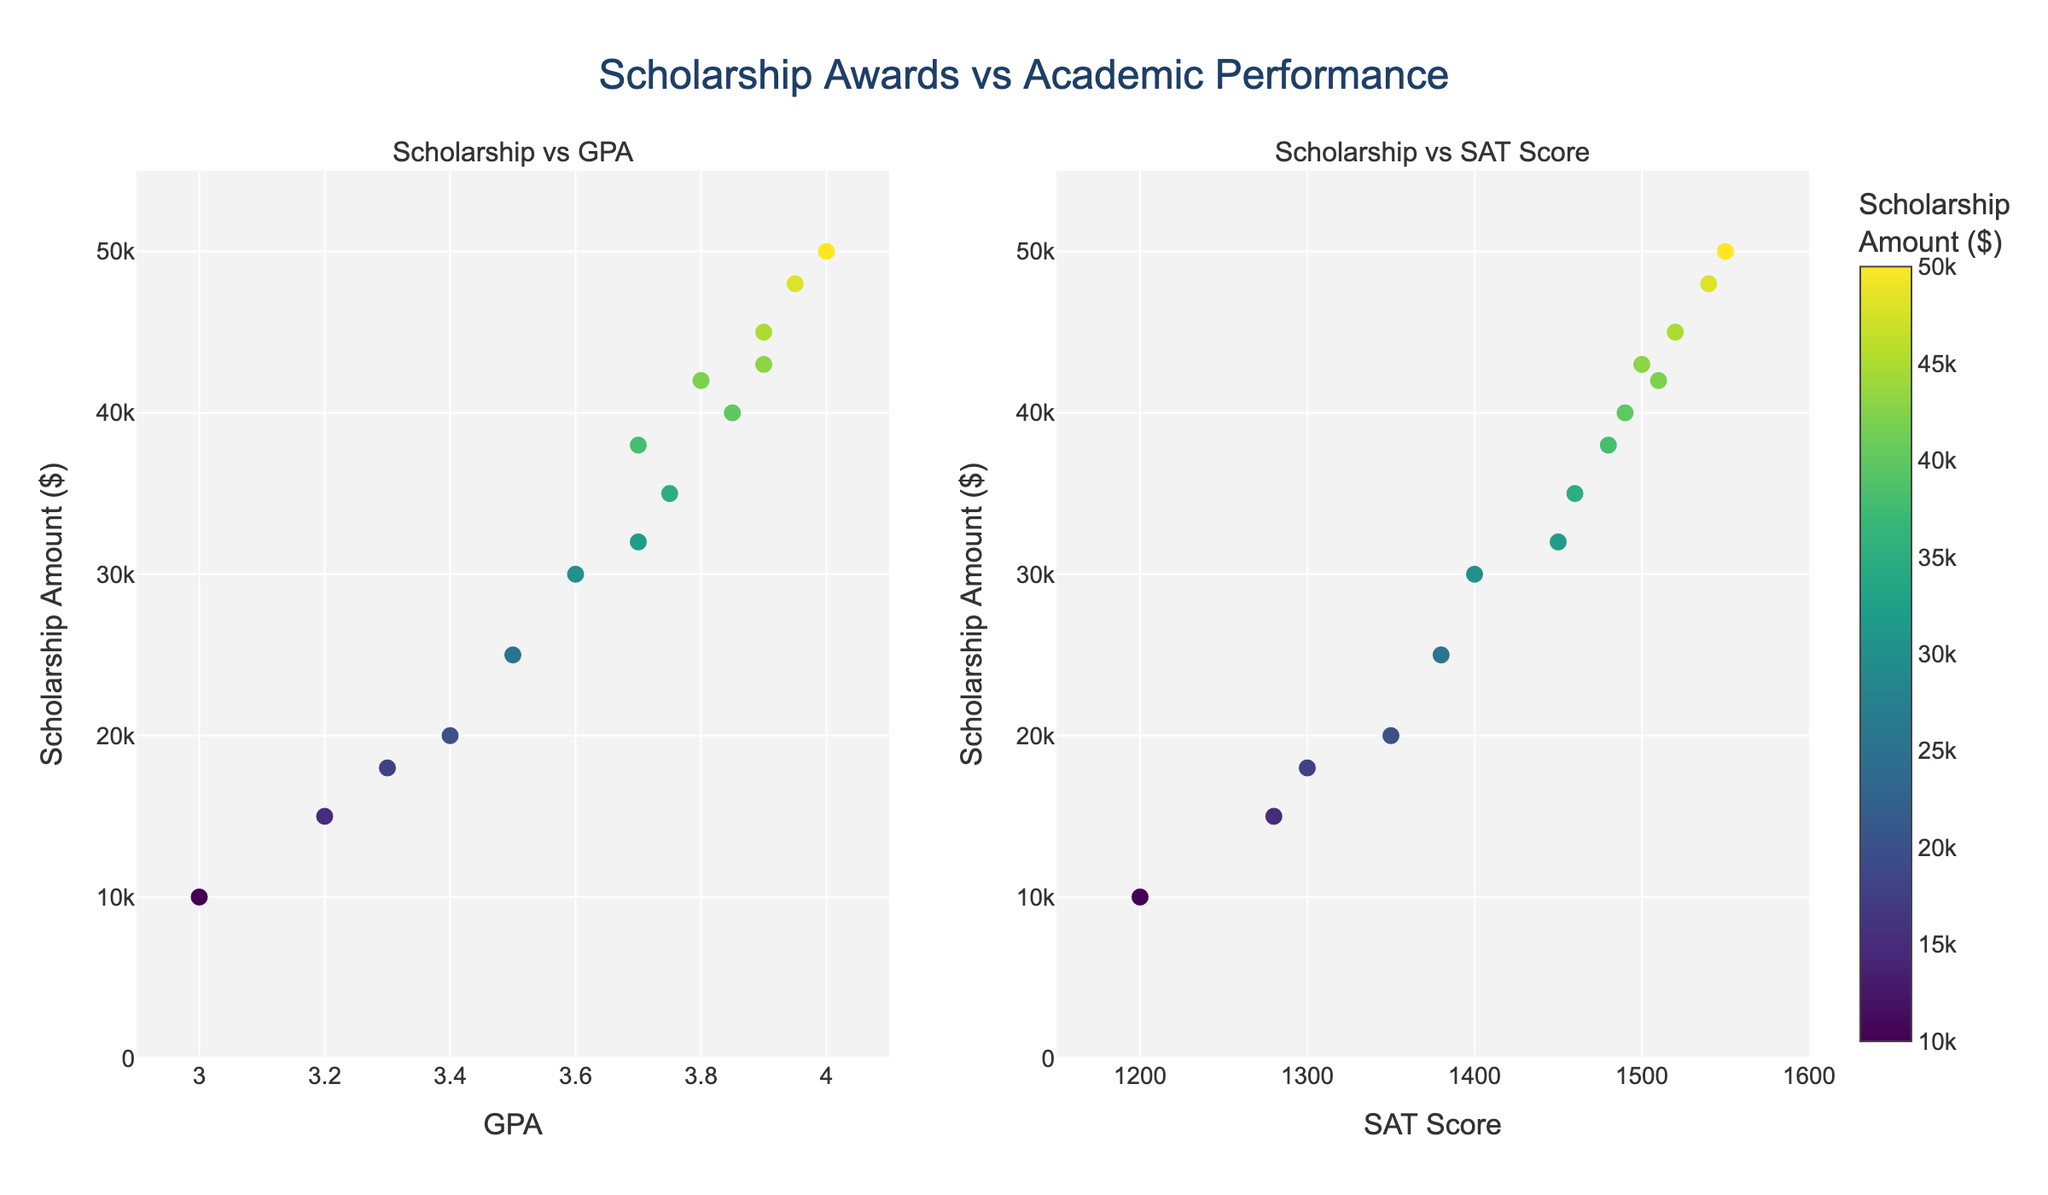what is the title of the plot? The title of the plot is typically displayed at the top center in a prominent position. By observing the provided plot, the title is "Scholarship Awards vs Academic Performance"
Answer: Scholarship Awards vs Academic Performance what is the x-axis label for the left subplot? The x-axis label for the left subplot can be found just below the horizontal axis. For the left subplot, which shows Scholarship vs GPA, the label is clearly marked as "GPA".
Answer: GPA how many data points are there in total? The total number of data points can be determined by counting the markers in both subplots. Each point represents a college. Counting all the colleges in the dataset shows there are 15 data points.
Answer: 15 which college offers the highest scholarship amount? Look at the y-axis representing the scholarship amounts in both subplots and find the data point with the highest position. By either GPA or SAT Score, Stanford University offers the highest amount of $50,000.
Answer: Stanford University what is the scholarship amount for a college with a GPA of 3.9? Locate the data points along the x-axis at GPA 3.9 in the left subplot. The colleges represented are Harvard University and Columbia University, with scholarship amounts of $45,000 and $43,000 respectively.
Answer: Harvard University: $45,000, Columbia University: $43,000 which college has a GPA of 3.7 and what is the corresponding scholarship amount? Find the data point at GPA 3.7 in the left subplot. The college with this GPA is Yale University, and the corresponding scholarship amount is $38,000.
Answer: Yale University, $38,000 is there any college offering a scholarship amount of $30,000? Check the y-axis in either subplot for a scholarship amount of $30,000 and find the corresponding college. This scholarship amount is offered by the University of California Berkeley.
Answer: Yes, University of California Berkeley compare the scholarships offered by colleges for students with a GPA of 3.5 and an SAT Score of 1380? Identify the data point at GPA 3.5 in the left subplot and SAT Score 1380 in the right subplot. Both values correspond to the University of Michigan, which offers a scholarship amount of $25,000.
Answer: Same college and amount: University of Michigan, $25,000 